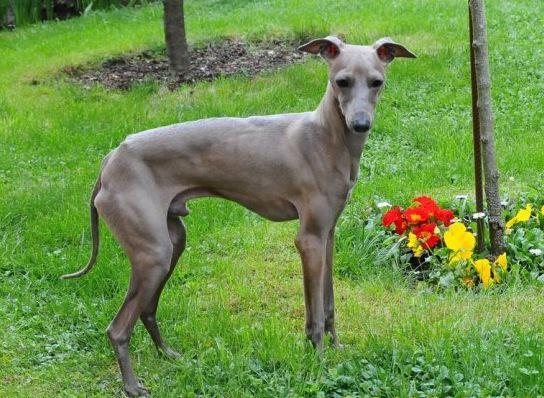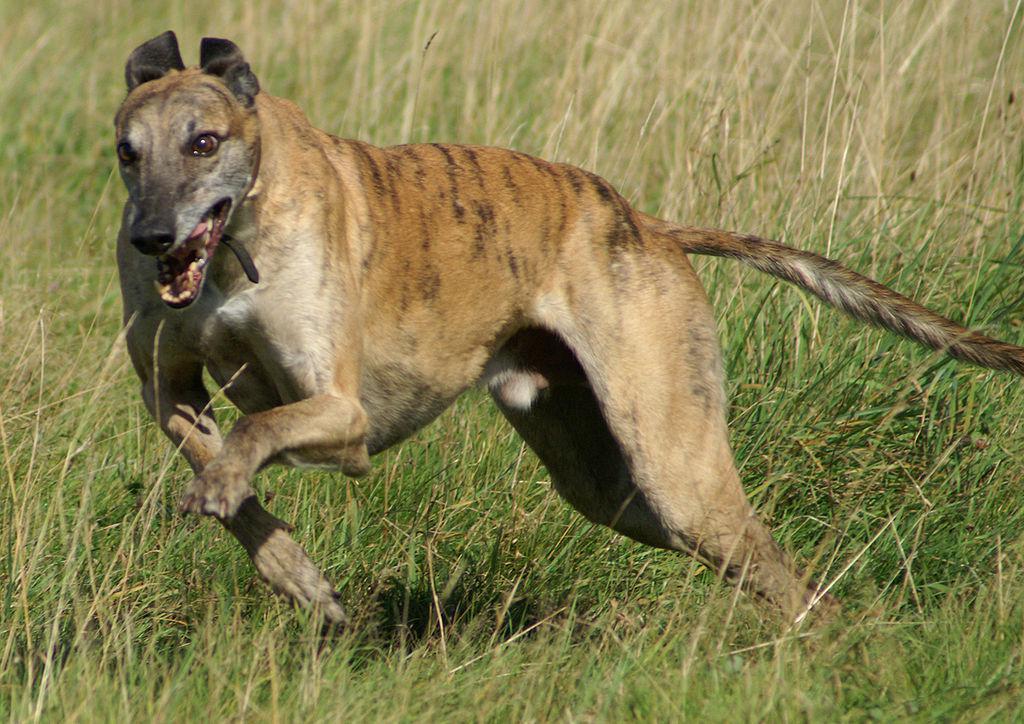The first image is the image on the left, the second image is the image on the right. Analyze the images presented: Is the assertion "An image shows a single dog bounding across a field, with its head partially forward." valid? Answer yes or no. Yes. The first image is the image on the left, the second image is the image on the right. Analyze the images presented: Is the assertion "An image contains exactly two dogs." valid? Answer yes or no. No. 